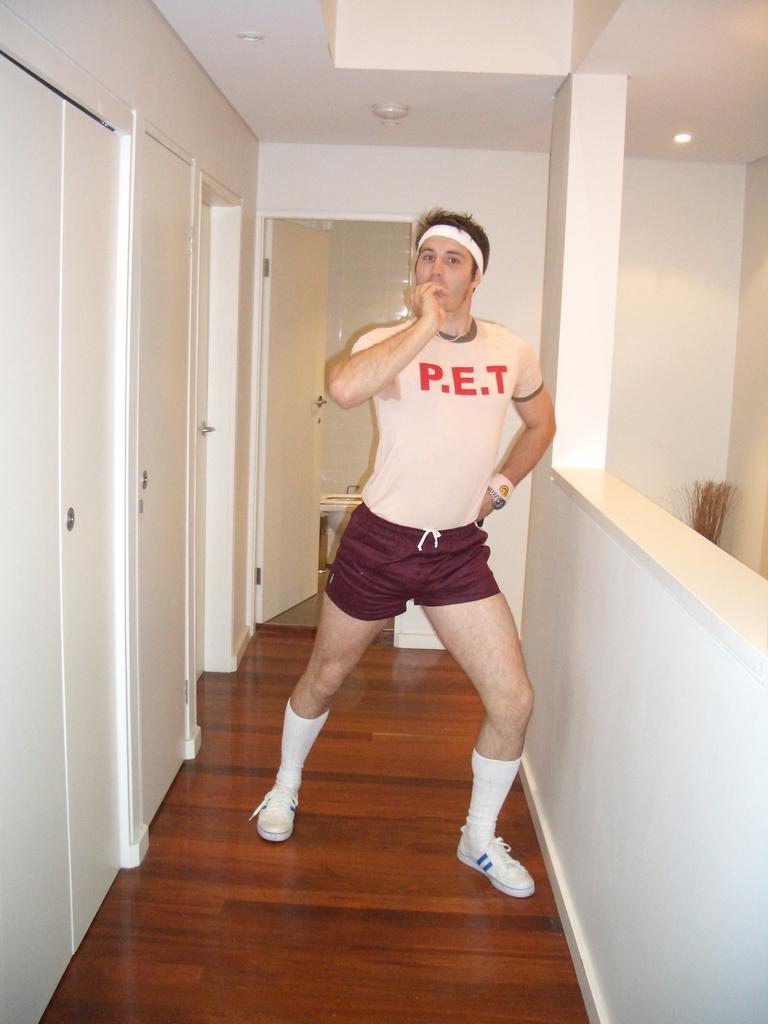<image>
Offer a succinct explanation of the picture presented. A man is standing in the hallway, with short red shorts on and a white shirt with the letters P.E.T on the front. 